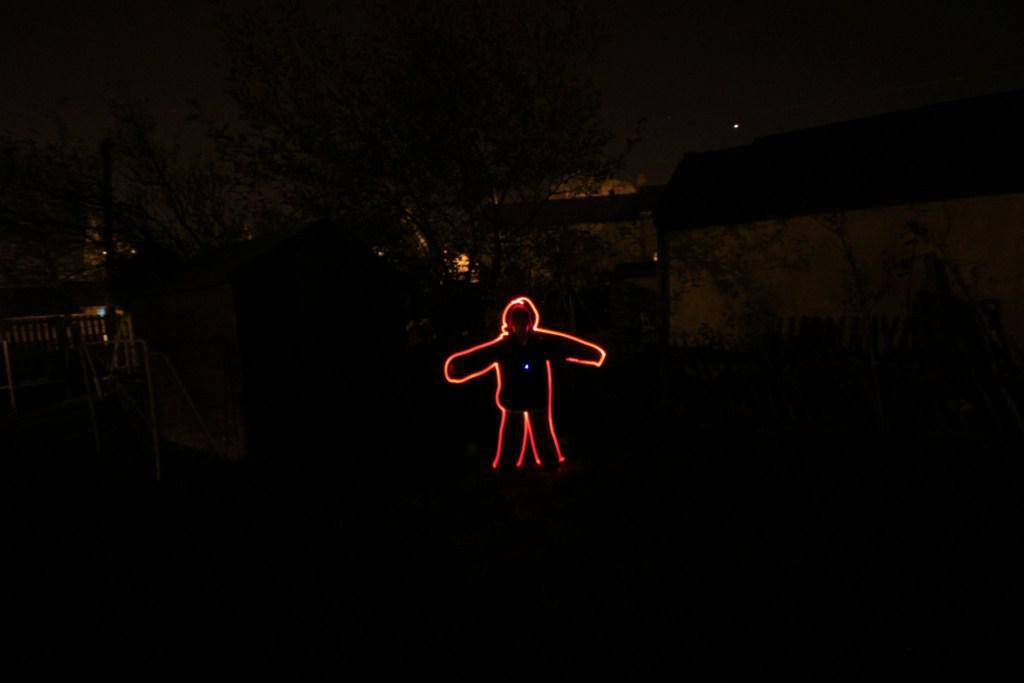What is the main subject of the picture? There is a red glowing man in the middle of the picture. What color is the background of the image? The background of the image is black in color. In what type of environment was the picture taken? The picture was taken in a dark environment. What degree does the actor in the image have? There is no actor present in the image, and therefore no degree can be attributed to anyone in the image. What book is the person in the image reading? There is no book visible in the image, and the person is not shown reading anything. 